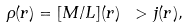<formula> <loc_0><loc_0><loc_500><loc_500>\rho ( r ) = [ M / L ] ( r ) \ > j ( r ) ,</formula> 